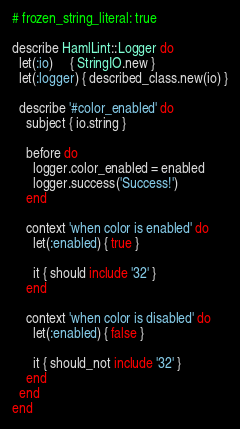<code> <loc_0><loc_0><loc_500><loc_500><_Ruby_># frozen_string_literal: true

describe HamlLint::Logger do
  let(:io)     { StringIO.new }
  let(:logger) { described_class.new(io) }

  describe '#color_enabled' do
    subject { io.string }

    before do
      logger.color_enabled = enabled
      logger.success('Success!')
    end

    context 'when color is enabled' do
      let(:enabled) { true }

      it { should include '32' }
    end

    context 'when color is disabled' do
      let(:enabled) { false }

      it { should_not include '32' }
    end
  end
end
</code> 